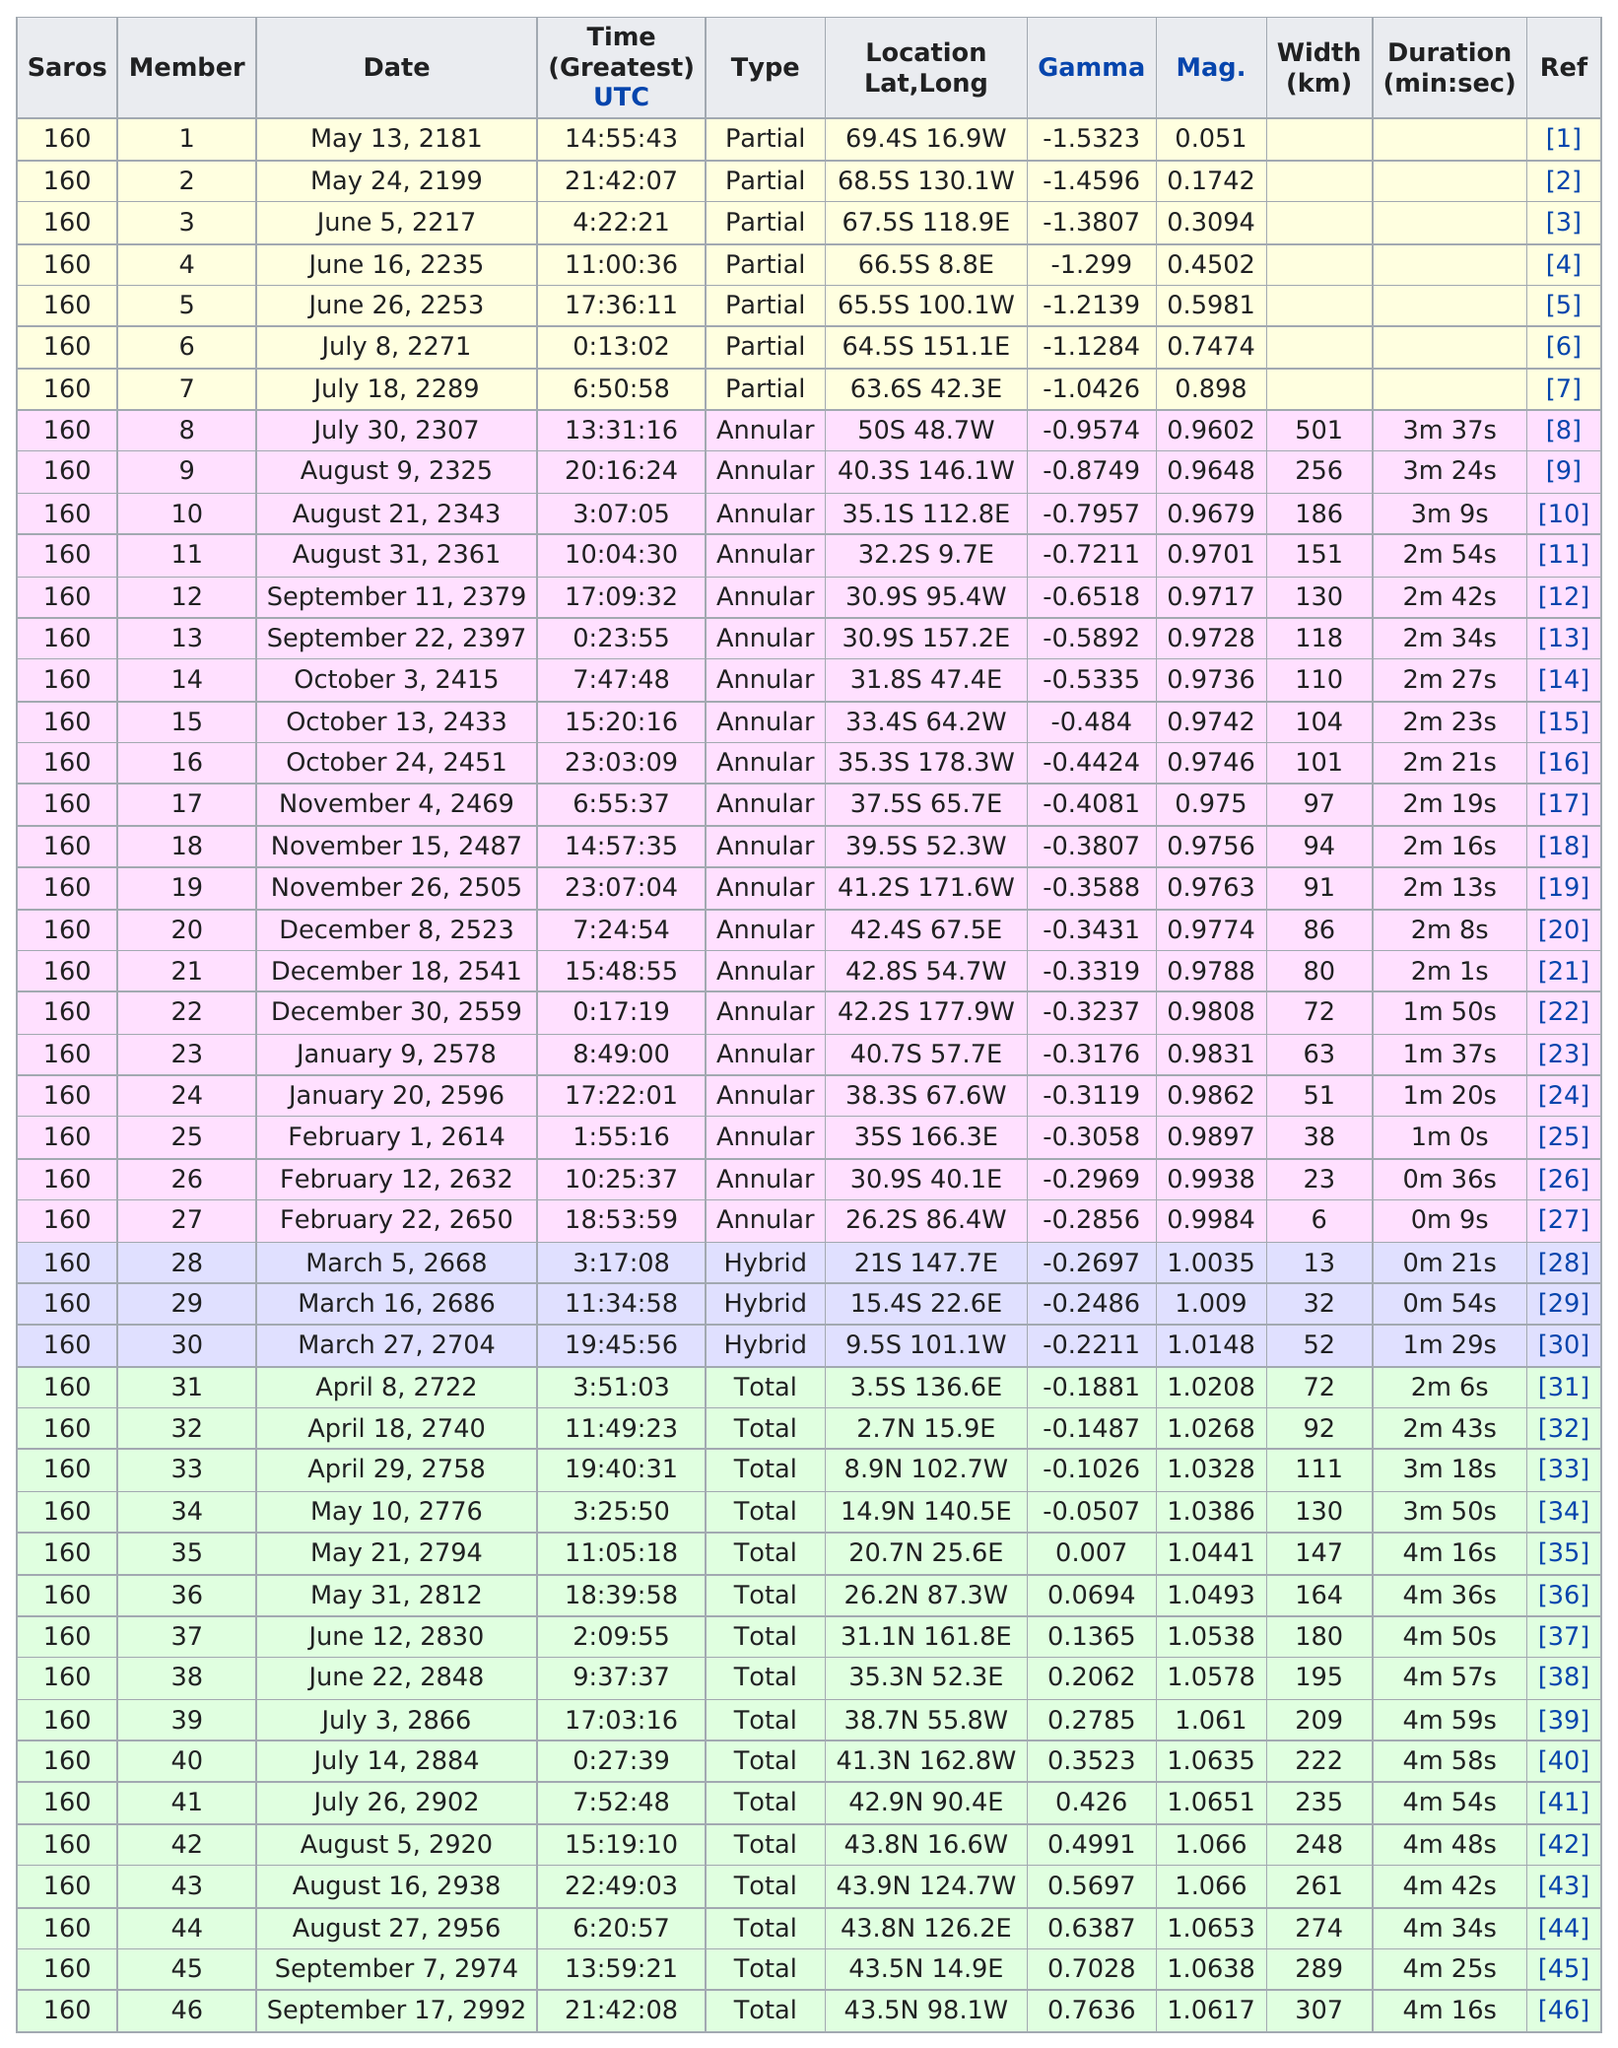List a handful of essential elements in this visual. The next solar saros after the May 24, 2199 solar saros will occur on June 5, 2217. On July 30, 2307, the saros lasted for 3 minutes and 37 seconds. Which one has a larger width, 8 or 21? 8... On October 3, 2415, the previous time for the saros cycle will be 7:47:48. Name one that has the same latitude as member number 12? 